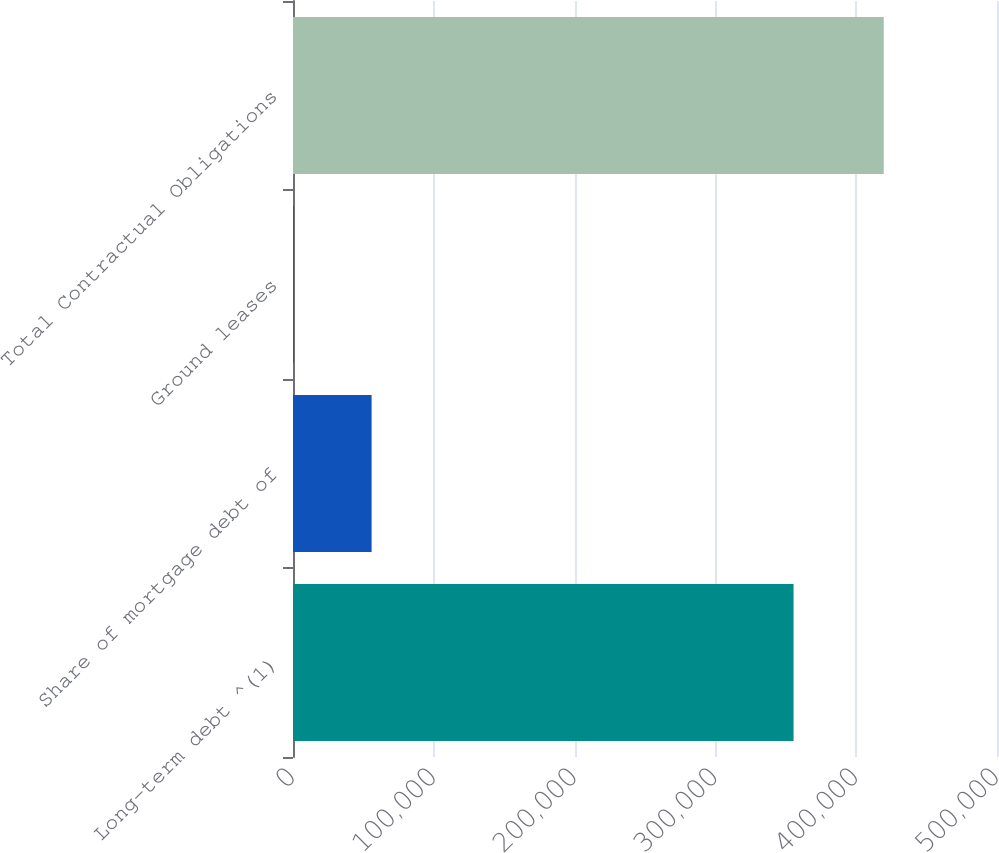Convert chart. <chart><loc_0><loc_0><loc_500><loc_500><bar_chart><fcel>Long-term debt ^(1)<fcel>Share of mortgage debt of<fcel>Ground leases<fcel>Total Contractual Obligations<nl><fcel>355506<fcel>55826<fcel>343<fcel>419563<nl></chart> 